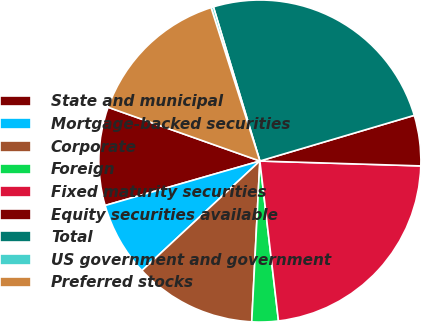Convert chart. <chart><loc_0><loc_0><loc_500><loc_500><pie_chart><fcel>State and municipal<fcel>Mortgage-backed securities<fcel>Corporate<fcel>Foreign<fcel>Fixed maturity securities<fcel>Equity securities available<fcel>Total<fcel>US government and government<fcel>Preferred stocks<nl><fcel>9.87%<fcel>7.46%<fcel>12.28%<fcel>2.65%<fcel>22.67%<fcel>5.06%<fcel>25.08%<fcel>0.24%<fcel>14.68%<nl></chart> 